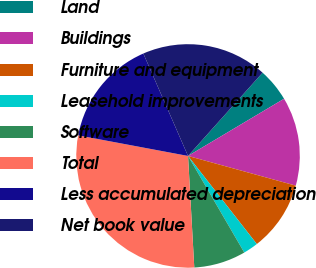Convert chart to OTSL. <chart><loc_0><loc_0><loc_500><loc_500><pie_chart><fcel>Land<fcel>Buildings<fcel>Furniture and equipment<fcel>Leasehold improvements<fcel>Software<fcel>Total<fcel>Less accumulated depreciation<fcel>Net book value<nl><fcel>4.83%<fcel>12.83%<fcel>10.17%<fcel>2.16%<fcel>7.5%<fcel>28.84%<fcel>15.5%<fcel>18.17%<nl></chart> 